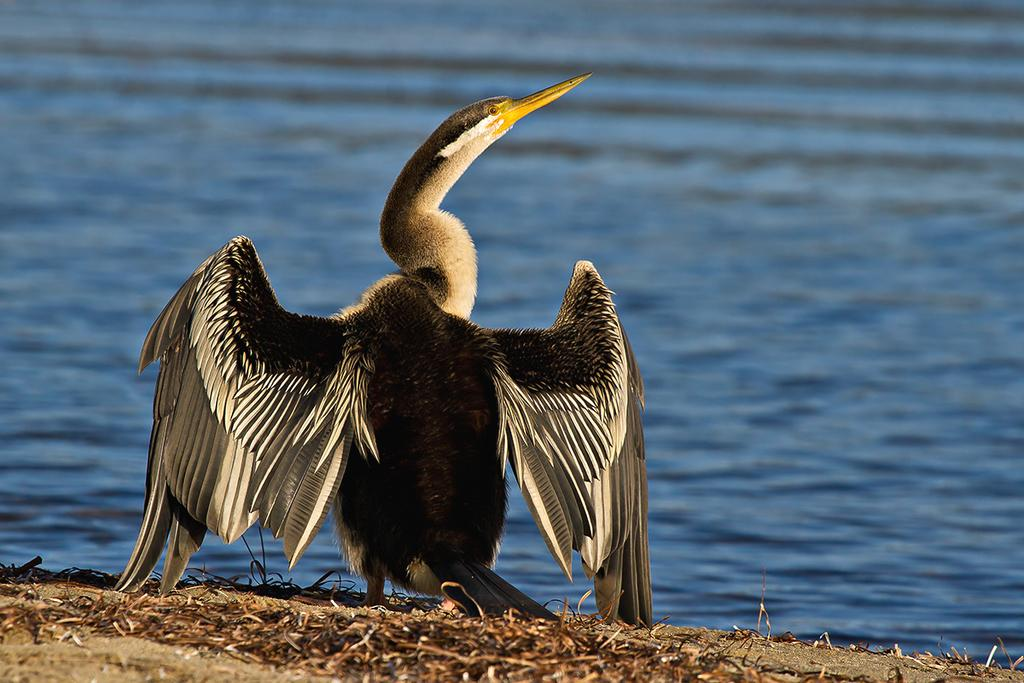What type of animal can be seen on the ground in the image? There is a bird on the ground in the image. What objects can be seen near the bird? Twigs are visible in the image. How would you describe the background of the image? The background of the image is blurred. What natural element can be seen in the background of the image? There is water visible in the background of the image. What color is the creator's blood in the image? There is no creator or blood present in the image. 